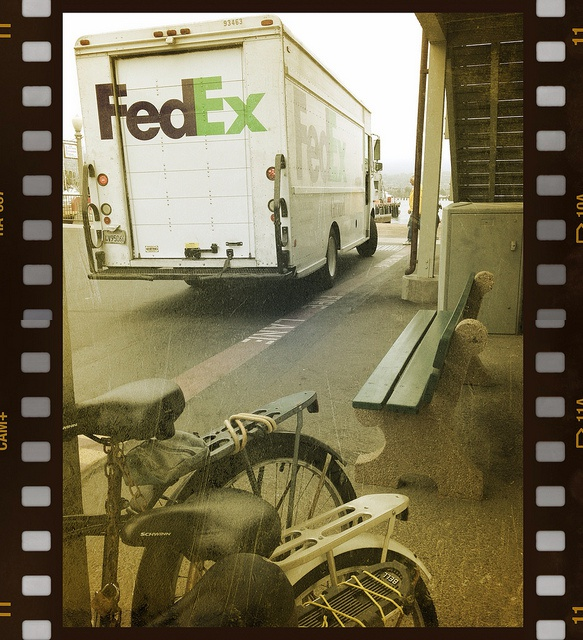Describe the objects in this image and their specific colors. I can see truck in black, ivory, beige, tan, and olive tones, bench in black, olive, and tan tones, bicycle in black and olive tones, bicycle in black and olive tones, and bicycle in black and olive tones in this image. 